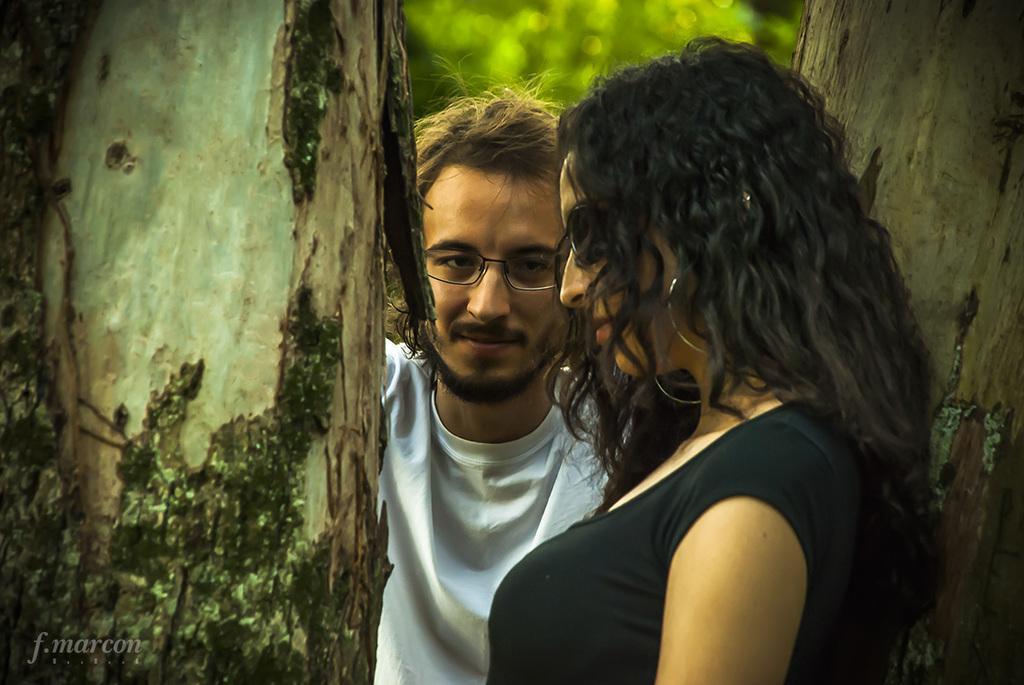In one or two sentences, can you explain what this image depicts? In this picture we can see a woman, man wore a spectacle and smiling and beside them we can see tree trunks and in the background we can see leaves and it is blur. 